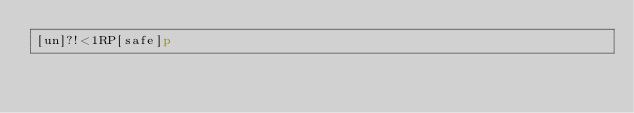<code> <loc_0><loc_0><loc_500><loc_500><_dc_>[un]?!<1RP[safe]p</code> 